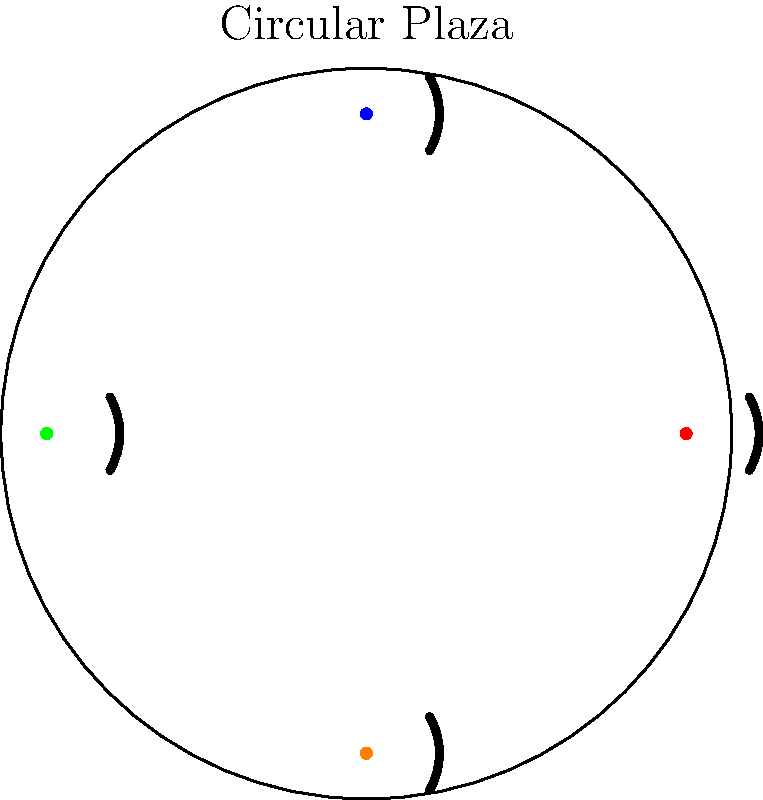In the circular plaza design shown above, how does the rotational symmetry of bench placement influence social interactions? Consider the potential for eye contact and conversation between individuals seated on different benches. To analyze how rotational symmetry in this plaza design influences social interactions, let's follow these steps:

1. Identify the rotational symmetry: The plaza has 4-fold rotational symmetry, with benches placed at 90° intervals.

2. Consider line of sight:
   - People sitting on opposite benches (e.g., red and green dots) have direct line of sight, facilitating eye contact.
   - Those on adjacent benches (e.g., red and blue dots) can easily turn their heads to make eye contact.

3. Analyze conversation potential:
   - The curved shape of each bench allows people to face slightly inward, promoting interaction within the plaza.
   - The distance between benches is consistent, creating equal opportunities for cross-plaza conversations.

4. Evaluate inclusivity:
   - The symmetrical design ensures no bench is privileged over others, promoting a sense of equality among users.
   - All users have similar views and access to the central area, encouraging shared experiences.

5. Consider group dynamics:
   - The arrangement allows for multiple small groups to form (on each bench) while still maintaining a connection to the larger space.
   - The open center enables larger group activities that can involve people from all benches.

6. Reflect on social cohesion:
   - The rotational symmetry creates a sense of unity and shared space, potentially fostering a feeling of community among plaza users.
   - The design encourages people to be aware of others in the space, potentially increasing social awareness and empathy.

This rotational symmetry in bench placement creates an environment that encourages eye contact, facilitates conversations across the plaza, promotes inclusivity, and fosters a sense of shared space and community among users.
Answer: Enhances social cohesion through equal sight lines, consistent inter-bench distances, and shared central space. 